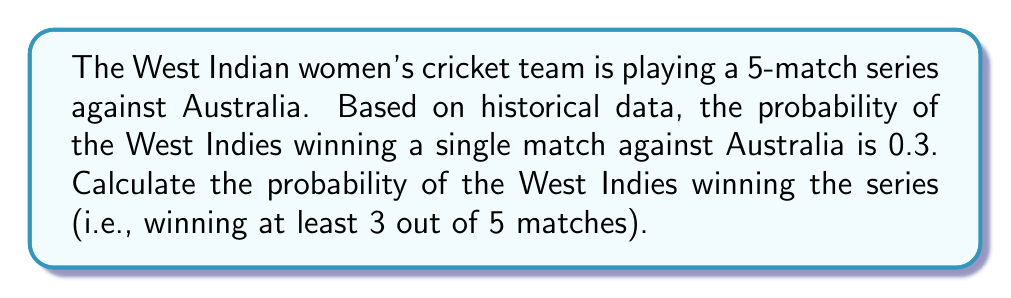Could you help me with this problem? To solve this problem, we need to use the binomial probability distribution. The probability of winning the series is the sum of the probabilities of winning exactly 3, 4, or 5 matches out of 5.

Let's define:
$p$ = probability of winning a single match = 0.3
$q$ = probability of losing a single match = 1 - p = 0.7
$n$ = total number of matches = 5

The probability of winning exactly $k$ matches out of $n$ is given by the binomial probability formula:

$$ P(X = k) = \binom{n}{k} p^k q^{n-k} $$

Where $\binom{n}{k}$ is the binomial coefficient, calculated as:

$$ \binom{n}{k} = \frac{n!}{k!(n-k)!} $$

Now, let's calculate the probabilities for winning 3, 4, and 5 matches:

1. Probability of winning exactly 3 matches:
   $P(X = 3) = \binom{5}{3} (0.3)^3 (0.7)^2 = 10 \times 0.027 \times 0.49 = 0.1323$

2. Probability of winning exactly 4 matches:
   $P(X = 4) = \binom{5}{4} (0.3)^4 (0.7)^1 = 5 \times 0.0081 \times 0.7 = 0.02835$

3. Probability of winning all 5 matches:
   $P(X = 5) = \binom{5}{5} (0.3)^5 (0.7)^0 = 1 \times 0.00243 \times 1 = 0.00243$

The probability of winning the series is the sum of these probabilities:

$P(\text{winning series}) = P(X = 3) + P(X = 4) + P(X = 5)$
$= 0.1323 + 0.02835 + 0.00243$
$= 0.16308$
Answer: The probability of the West Indian women's cricket team winning the series against Australia is approximately 0.16308 or 16.31%. 